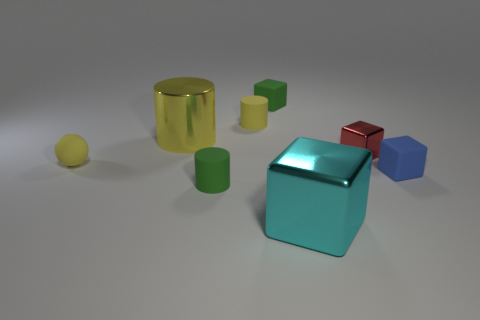What shape is the big shiny object that is the same color as the tiny sphere? The big shiny object sharing the color with the tiny sphere in the image is a cylinder. Its reflective surface suggests it's made of a material like shiny metal or polished plastic, adding an interesting visual contrast with the matte surfaces of the other objects. 